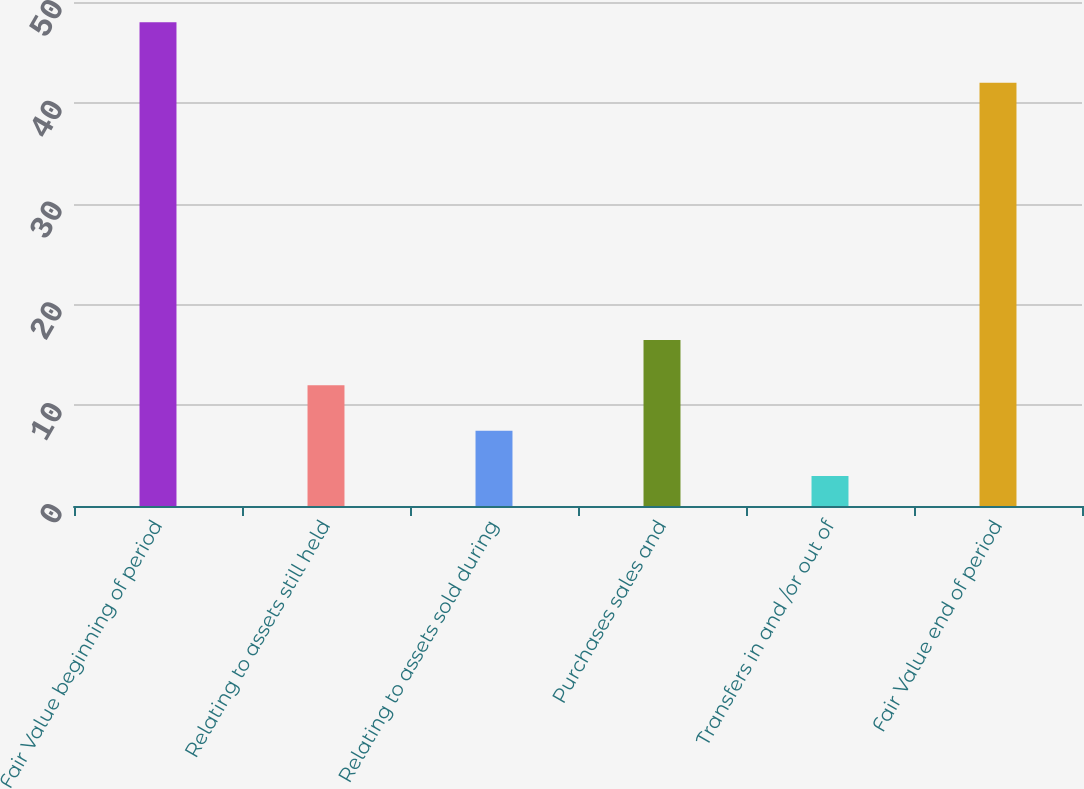Convert chart to OTSL. <chart><loc_0><loc_0><loc_500><loc_500><bar_chart><fcel>Fair Value beginning of period<fcel>Relating to assets still held<fcel>Relating to assets sold during<fcel>Purchases sales and<fcel>Transfers in and /or out of<fcel>Fair Value end of period<nl><fcel>48<fcel>11.97<fcel>7.47<fcel>16.47<fcel>2.97<fcel>42<nl></chart> 